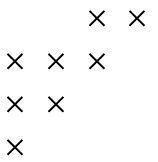<formula> <loc_0><loc_0><loc_500><loc_500>\begin{matrix} & & \times & \times \\ \times & \times & \times & \\ \times & \times & & \\ \times & & & \end{matrix}</formula> 